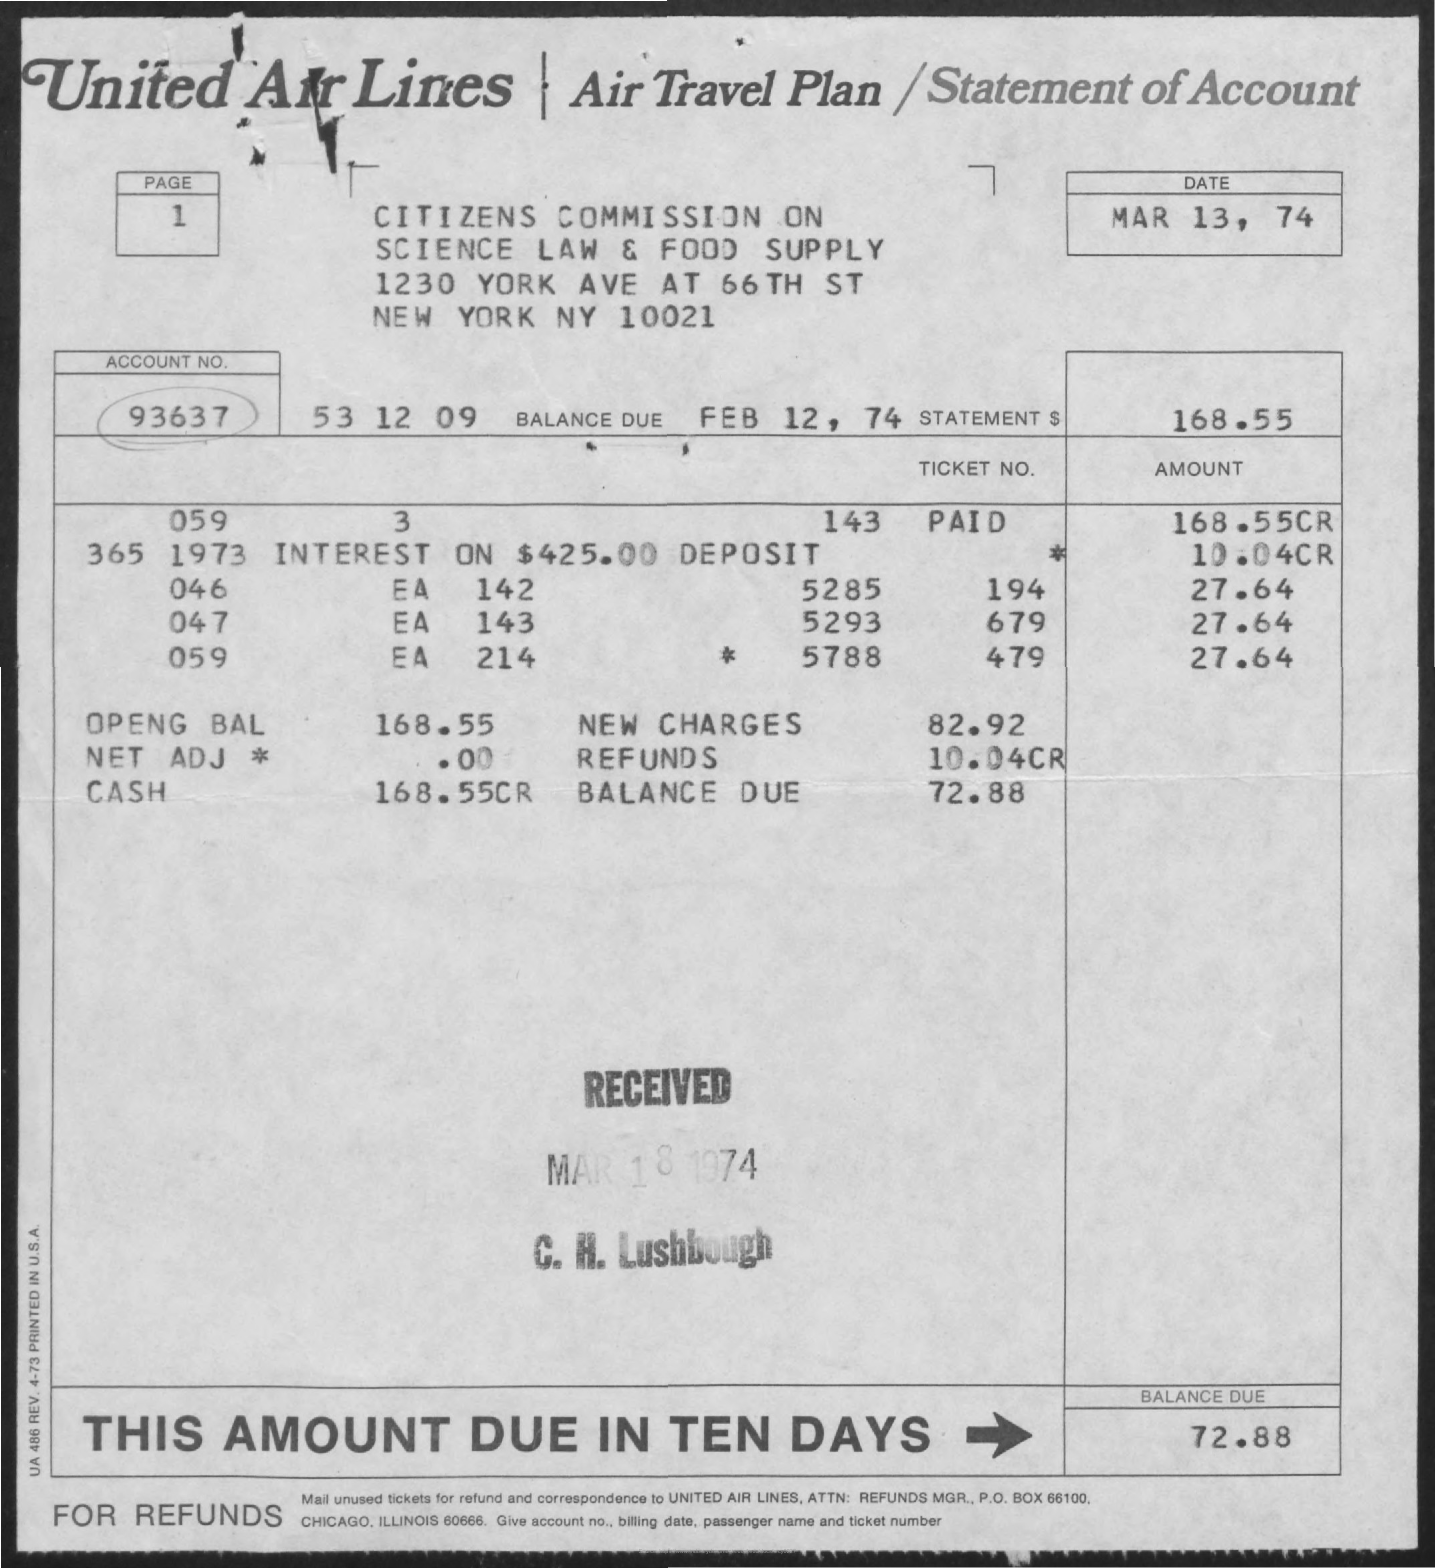Which company's name is mentioned?
Provide a short and direct response. United Air Lines. When is the document dated?
Your answer should be compact. MAR 13, 74. What is the Account Number?
Provide a succinct answer. 93637. When is the balance due?
Keep it short and to the point. FEB 12, 74. What amount is due in ten days?
Keep it short and to the point. BALANCE DUE. What is the page number?
Give a very brief answer. 1. 